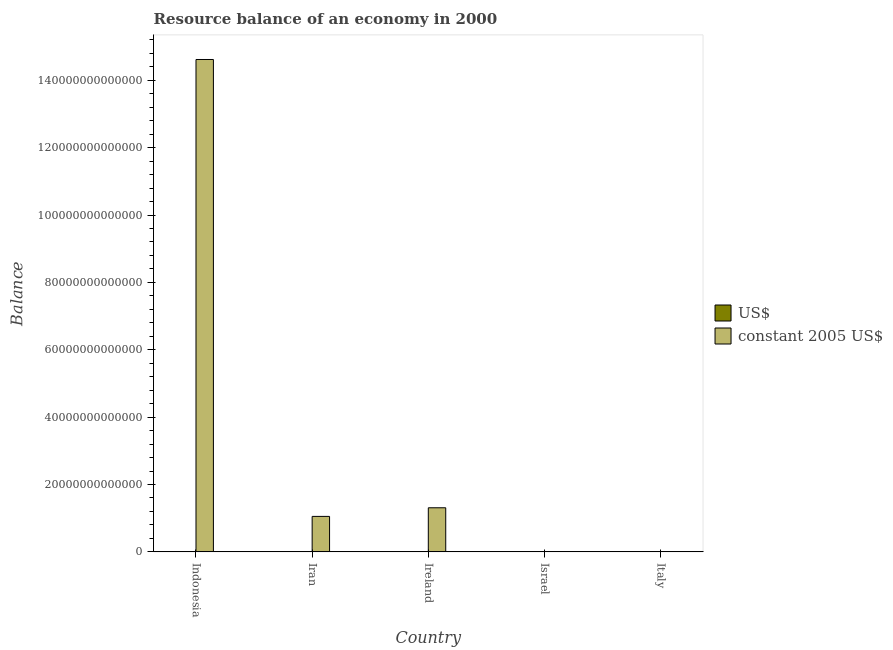How many different coloured bars are there?
Ensure brevity in your answer.  2. How many groups of bars are there?
Keep it short and to the point. 5. Are the number of bars per tick equal to the number of legend labels?
Give a very brief answer. Yes. Are the number of bars on each tick of the X-axis equal?
Offer a terse response. Yes. What is the label of the 1st group of bars from the left?
Your answer should be very brief. Indonesia. What is the resource balance in constant us$ in Ireland?
Give a very brief answer. 1.31e+13. Across all countries, what is the maximum resource balance in constant us$?
Provide a succinct answer. 1.46e+14. Across all countries, what is the minimum resource balance in us$?
Offer a very short reply. 6.16e+07. What is the total resource balance in constant us$ in the graph?
Give a very brief answer. 1.70e+14. What is the difference between the resource balance in constant us$ in Indonesia and that in Ireland?
Provide a short and direct response. 1.33e+14. What is the difference between the resource balance in constant us$ in Iran and the resource balance in us$ in Ireland?
Provide a short and direct response. 1.05e+13. What is the average resource balance in us$ per country?
Your answer should be compact. 8.54e+09. What is the difference between the resource balance in constant us$ and resource balance in us$ in Ireland?
Provide a short and direct response. 1.31e+13. What is the ratio of the resource balance in us$ in Indonesia to that in Ireland?
Give a very brief answer. 1.26. Is the resource balance in us$ in Iran less than that in Italy?
Offer a very short reply. Yes. What is the difference between the highest and the second highest resource balance in us$?
Ensure brevity in your answer.  3.54e+09. What is the difference between the highest and the lowest resource balance in constant us$?
Give a very brief answer. 1.46e+14. In how many countries, is the resource balance in constant us$ greater than the average resource balance in constant us$ taken over all countries?
Provide a succinct answer. 1. What does the 2nd bar from the left in Iran represents?
Ensure brevity in your answer.  Constant 2005 us$. What does the 2nd bar from the right in Israel represents?
Offer a terse response. US$. How many bars are there?
Offer a terse response. 10. Are all the bars in the graph horizontal?
Provide a succinct answer. No. What is the difference between two consecutive major ticks on the Y-axis?
Your answer should be very brief. 2.00e+13. Does the graph contain grids?
Offer a terse response. No. Where does the legend appear in the graph?
Provide a succinct answer. Center right. How many legend labels are there?
Ensure brevity in your answer.  2. What is the title of the graph?
Your answer should be compact. Resource balance of an economy in 2000. What is the label or title of the X-axis?
Ensure brevity in your answer.  Country. What is the label or title of the Y-axis?
Give a very brief answer. Balance. What is the Balance of US$ in Indonesia?
Your response must be concise. 1.74e+1. What is the Balance of constant 2005 US$ in Indonesia?
Ensure brevity in your answer.  1.46e+14. What is the Balance in US$ in Iran?
Your answer should be compact. 1.84e+09. What is the Balance in constant 2005 US$ in Iran?
Your response must be concise. 1.05e+13. What is the Balance of US$ in Ireland?
Provide a succinct answer. 1.38e+1. What is the Balance in constant 2005 US$ in Ireland?
Your answer should be very brief. 1.31e+13. What is the Balance of US$ in Israel?
Provide a succinct answer. 6.16e+07. What is the Balance in constant 2005 US$ in Israel?
Your answer should be compact. 1.50e+1. What is the Balance in US$ in Italy?
Keep it short and to the point. 9.60e+09. What is the Balance of constant 2005 US$ in Italy?
Offer a very short reply. 2.51e+08. Across all countries, what is the maximum Balance in US$?
Your answer should be very brief. 1.74e+1. Across all countries, what is the maximum Balance of constant 2005 US$?
Give a very brief answer. 1.46e+14. Across all countries, what is the minimum Balance of US$?
Your answer should be compact. 6.16e+07. Across all countries, what is the minimum Balance of constant 2005 US$?
Your response must be concise. 2.51e+08. What is the total Balance in US$ in the graph?
Ensure brevity in your answer.  4.27e+1. What is the total Balance in constant 2005 US$ in the graph?
Ensure brevity in your answer.  1.70e+14. What is the difference between the Balance of US$ in Indonesia and that in Iran?
Your response must be concise. 1.55e+1. What is the difference between the Balance of constant 2005 US$ in Indonesia and that in Iran?
Provide a succinct answer. 1.36e+14. What is the difference between the Balance in US$ in Indonesia and that in Ireland?
Make the answer very short. 3.54e+09. What is the difference between the Balance of constant 2005 US$ in Indonesia and that in Ireland?
Offer a terse response. 1.33e+14. What is the difference between the Balance of US$ in Indonesia and that in Israel?
Keep it short and to the point. 1.73e+1. What is the difference between the Balance in constant 2005 US$ in Indonesia and that in Israel?
Your response must be concise. 1.46e+14. What is the difference between the Balance of US$ in Indonesia and that in Italy?
Your answer should be compact. 7.75e+09. What is the difference between the Balance in constant 2005 US$ in Indonesia and that in Italy?
Your answer should be very brief. 1.46e+14. What is the difference between the Balance in US$ in Iran and that in Ireland?
Ensure brevity in your answer.  -1.20e+1. What is the difference between the Balance in constant 2005 US$ in Iran and that in Ireland?
Provide a short and direct response. -2.56e+12. What is the difference between the Balance in US$ in Iran and that in Israel?
Your response must be concise. 1.78e+09. What is the difference between the Balance of constant 2005 US$ in Iran and that in Israel?
Your answer should be very brief. 1.05e+13. What is the difference between the Balance of US$ in Iran and that in Italy?
Make the answer very short. -7.77e+09. What is the difference between the Balance of constant 2005 US$ in Iran and that in Italy?
Your response must be concise. 1.05e+13. What is the difference between the Balance in US$ in Ireland and that in Israel?
Offer a very short reply. 1.38e+1. What is the difference between the Balance in constant 2005 US$ in Ireland and that in Israel?
Keep it short and to the point. 1.31e+13. What is the difference between the Balance in US$ in Ireland and that in Italy?
Your response must be concise. 4.22e+09. What is the difference between the Balance of constant 2005 US$ in Ireland and that in Italy?
Offer a very short reply. 1.31e+13. What is the difference between the Balance of US$ in Israel and that in Italy?
Provide a short and direct response. -9.54e+09. What is the difference between the Balance of constant 2005 US$ in Israel and that in Italy?
Your answer should be very brief. 1.47e+1. What is the difference between the Balance in US$ in Indonesia and the Balance in constant 2005 US$ in Iran?
Keep it short and to the point. -1.05e+13. What is the difference between the Balance in US$ in Indonesia and the Balance in constant 2005 US$ in Ireland?
Offer a very short reply. -1.31e+13. What is the difference between the Balance in US$ in Indonesia and the Balance in constant 2005 US$ in Israel?
Your answer should be compact. 2.36e+09. What is the difference between the Balance in US$ in Indonesia and the Balance in constant 2005 US$ in Italy?
Your response must be concise. 1.71e+1. What is the difference between the Balance in US$ in Iran and the Balance in constant 2005 US$ in Ireland?
Give a very brief answer. -1.31e+13. What is the difference between the Balance of US$ in Iran and the Balance of constant 2005 US$ in Israel?
Make the answer very short. -1.32e+1. What is the difference between the Balance in US$ in Iran and the Balance in constant 2005 US$ in Italy?
Your answer should be very brief. 1.59e+09. What is the difference between the Balance of US$ in Ireland and the Balance of constant 2005 US$ in Israel?
Your answer should be very brief. -1.18e+09. What is the difference between the Balance of US$ in Ireland and the Balance of constant 2005 US$ in Italy?
Keep it short and to the point. 1.36e+1. What is the difference between the Balance in US$ in Israel and the Balance in constant 2005 US$ in Italy?
Provide a short and direct response. -1.89e+08. What is the average Balance in US$ per country?
Keep it short and to the point. 8.54e+09. What is the average Balance in constant 2005 US$ per country?
Offer a very short reply. 3.40e+13. What is the difference between the Balance of US$ and Balance of constant 2005 US$ in Indonesia?
Offer a terse response. -1.46e+14. What is the difference between the Balance in US$ and Balance in constant 2005 US$ in Iran?
Your answer should be very brief. -1.05e+13. What is the difference between the Balance in US$ and Balance in constant 2005 US$ in Ireland?
Make the answer very short. -1.31e+13. What is the difference between the Balance of US$ and Balance of constant 2005 US$ in Israel?
Ensure brevity in your answer.  -1.49e+1. What is the difference between the Balance of US$ and Balance of constant 2005 US$ in Italy?
Keep it short and to the point. 9.35e+09. What is the ratio of the Balance in US$ in Indonesia to that in Iran?
Provide a succinct answer. 9.44. What is the ratio of the Balance of constant 2005 US$ in Indonesia to that in Iran?
Ensure brevity in your answer.  13.88. What is the ratio of the Balance of US$ in Indonesia to that in Ireland?
Ensure brevity in your answer.  1.26. What is the ratio of the Balance in constant 2005 US$ in Indonesia to that in Ireland?
Offer a terse response. 11.17. What is the ratio of the Balance of US$ in Indonesia to that in Israel?
Ensure brevity in your answer.  281.94. What is the ratio of the Balance of constant 2005 US$ in Indonesia to that in Israel?
Offer a terse response. 9744.97. What is the ratio of the Balance of US$ in Indonesia to that in Italy?
Provide a short and direct response. 1.81. What is the ratio of the Balance in constant 2005 US$ in Indonesia to that in Italy?
Make the answer very short. 5.82e+05. What is the ratio of the Balance in US$ in Iran to that in Ireland?
Your response must be concise. 0.13. What is the ratio of the Balance of constant 2005 US$ in Iran to that in Ireland?
Your answer should be very brief. 0.8. What is the ratio of the Balance in US$ in Iran to that in Israel?
Provide a short and direct response. 29.85. What is the ratio of the Balance in constant 2005 US$ in Iran to that in Israel?
Your answer should be very brief. 702.14. What is the ratio of the Balance in US$ in Iran to that in Italy?
Provide a short and direct response. 0.19. What is the ratio of the Balance in constant 2005 US$ in Iran to that in Italy?
Provide a short and direct response. 4.20e+04. What is the ratio of the Balance in US$ in Ireland to that in Israel?
Provide a short and direct response. 224.49. What is the ratio of the Balance of constant 2005 US$ in Ireland to that in Israel?
Keep it short and to the point. 872.76. What is the ratio of the Balance of US$ in Ireland to that in Italy?
Your response must be concise. 1.44. What is the ratio of the Balance in constant 2005 US$ in Ireland to that in Italy?
Your answer should be very brief. 5.22e+04. What is the ratio of the Balance of US$ in Israel to that in Italy?
Provide a short and direct response. 0.01. What is the ratio of the Balance in constant 2005 US$ in Israel to that in Italy?
Provide a short and direct response. 59.76. What is the difference between the highest and the second highest Balance in US$?
Your answer should be very brief. 3.54e+09. What is the difference between the highest and the second highest Balance of constant 2005 US$?
Your answer should be very brief. 1.33e+14. What is the difference between the highest and the lowest Balance in US$?
Provide a short and direct response. 1.73e+1. What is the difference between the highest and the lowest Balance of constant 2005 US$?
Provide a short and direct response. 1.46e+14. 